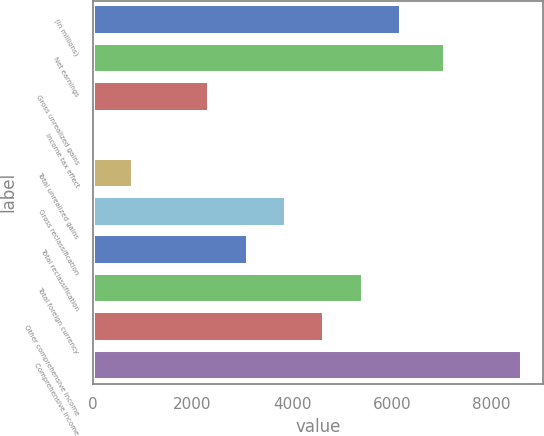Convert chart. <chart><loc_0><loc_0><loc_500><loc_500><bar_chart><fcel>(in millions)<fcel>Net earnings<fcel>Gross unrealized gains<fcel>Income tax effect<fcel>Total unrealized gains<fcel>Gross reclassification<fcel>Total reclassification<fcel>Total foreign currency<fcel>Other comprehensive income<fcel>Comprehensive income<nl><fcel>6186<fcel>7073<fcel>2336<fcel>26<fcel>796<fcel>3876<fcel>3106<fcel>5416<fcel>4646<fcel>8613<nl></chart> 